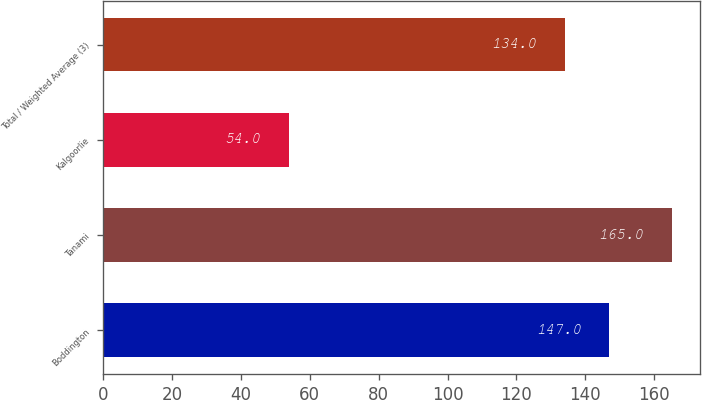Convert chart to OTSL. <chart><loc_0><loc_0><loc_500><loc_500><bar_chart><fcel>Boddington<fcel>Tanami<fcel>Kalgoorlie<fcel>Total / Weighted Average (3)<nl><fcel>147<fcel>165<fcel>54<fcel>134<nl></chart> 